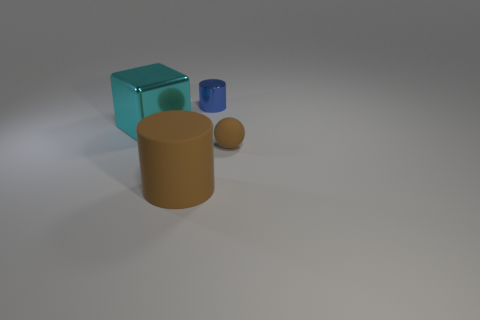How many things are either large purple rubber spheres or objects that are on the left side of the tiny shiny cylinder?
Ensure brevity in your answer.  2. What number of other things are made of the same material as the blue cylinder?
Provide a succinct answer. 1. How many things are either large matte cylinders or small metal things?
Make the answer very short. 2. Are there more matte spheres that are right of the small rubber thing than big objects right of the blue metallic thing?
Provide a short and direct response. No. There is a object in front of the sphere; does it have the same color as the small thing right of the small blue cylinder?
Your response must be concise. Yes. What is the size of the shiny object right of the large thing to the left of the brown rubber thing that is to the left of the tiny brown matte object?
Give a very brief answer. Small. There is another rubber thing that is the same shape as the blue thing; what is its color?
Offer a terse response. Brown. Is the number of large brown matte cylinders that are in front of the tiny blue shiny cylinder greater than the number of small purple shiny balls?
Make the answer very short. Yes. Do the large brown rubber thing and the brown thing on the right side of the large brown matte object have the same shape?
Ensure brevity in your answer.  No. There is another rubber object that is the same shape as the blue thing; what size is it?
Provide a short and direct response. Large. 